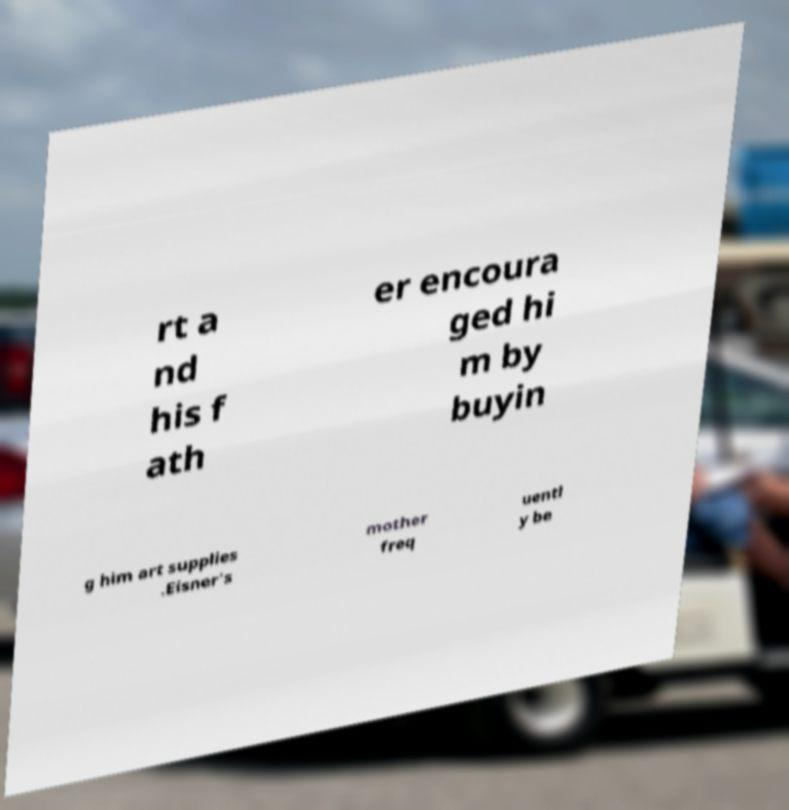Please read and relay the text visible in this image. What does it say? rt a nd his f ath er encoura ged hi m by buyin g him art supplies .Eisner's mother freq uentl y be 